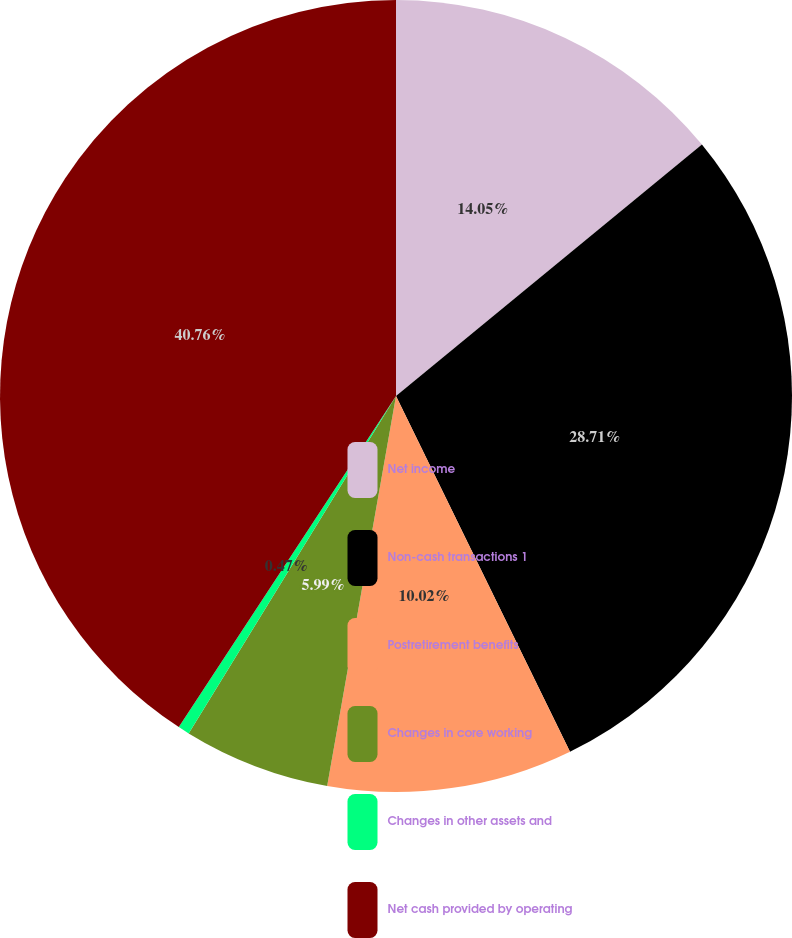Convert chart. <chart><loc_0><loc_0><loc_500><loc_500><pie_chart><fcel>Net income<fcel>Non-cash transactions 1<fcel>Postretirement benefits<fcel>Changes in core working<fcel>Changes in other assets and<fcel>Net cash provided by operating<nl><fcel>14.05%<fcel>28.71%<fcel>10.02%<fcel>5.99%<fcel>0.47%<fcel>40.76%<nl></chart> 